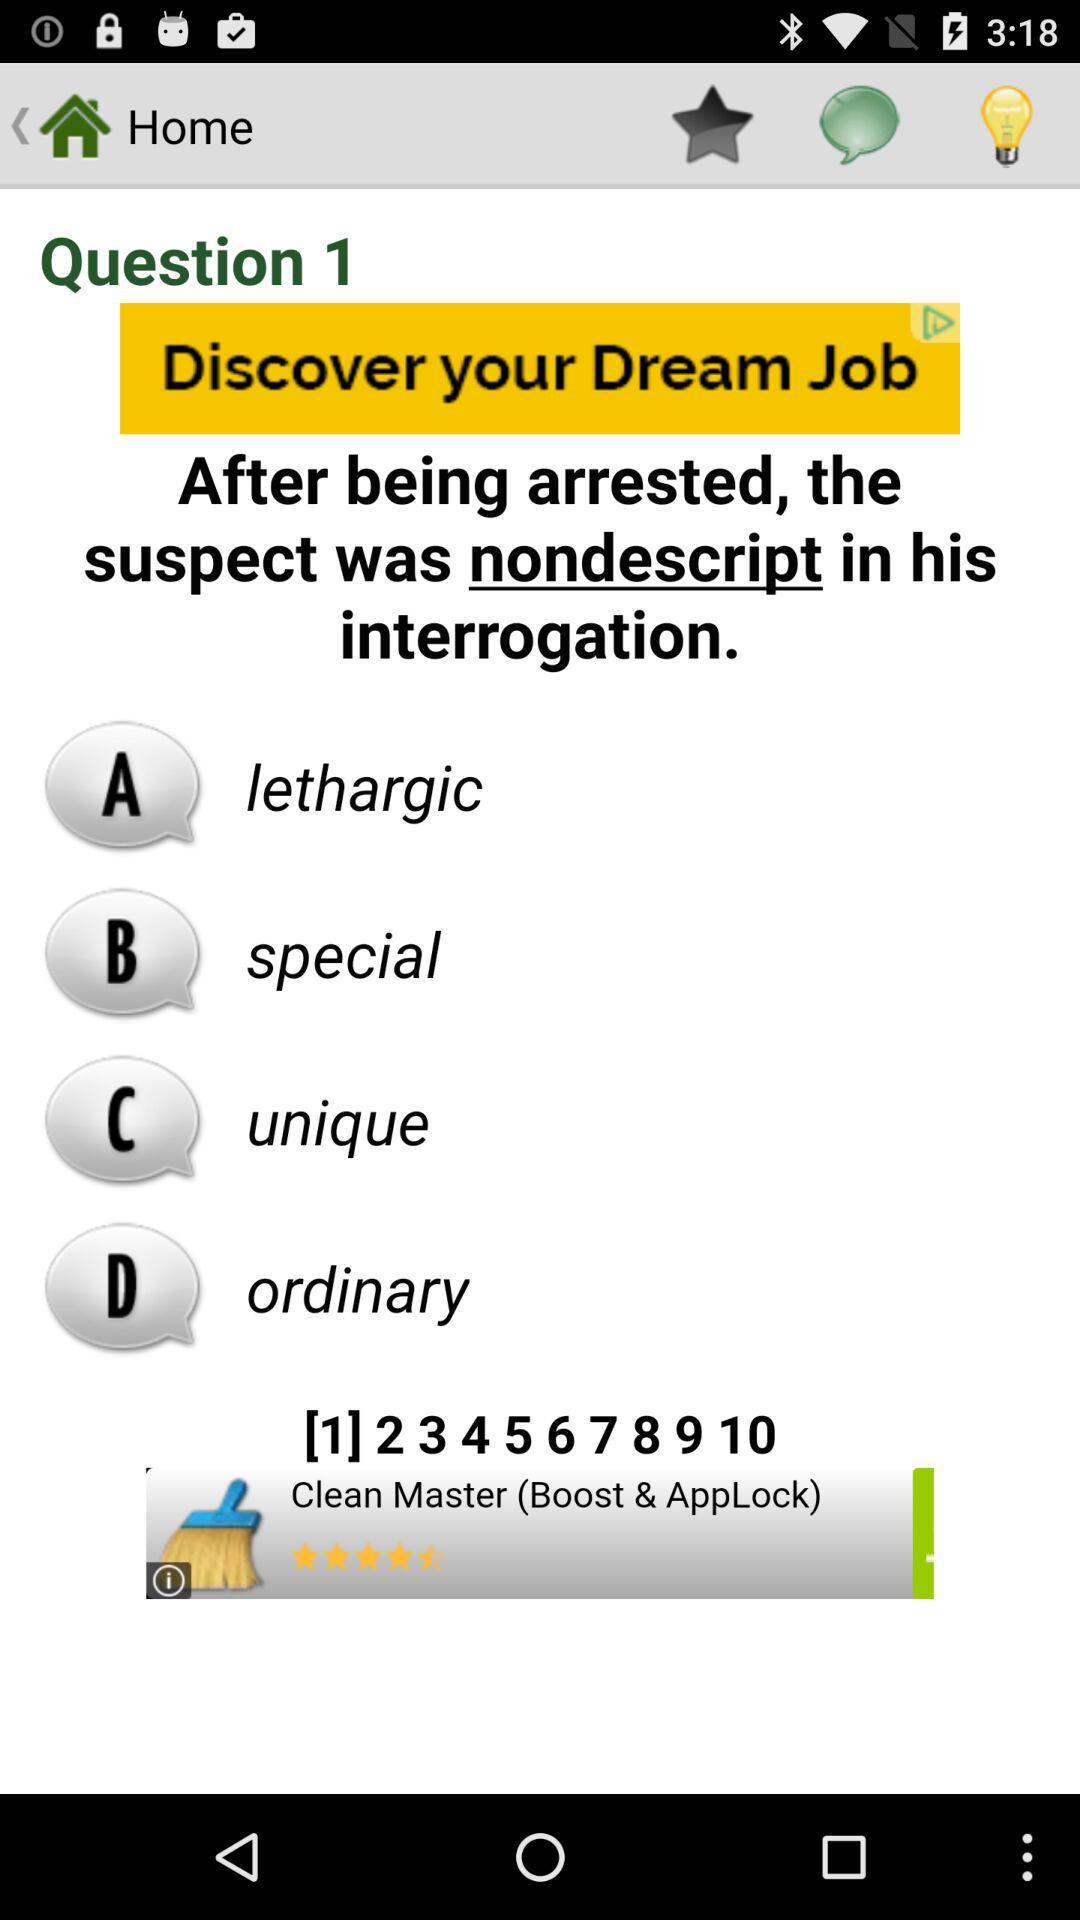How many questions are there? There are 10 questions. 